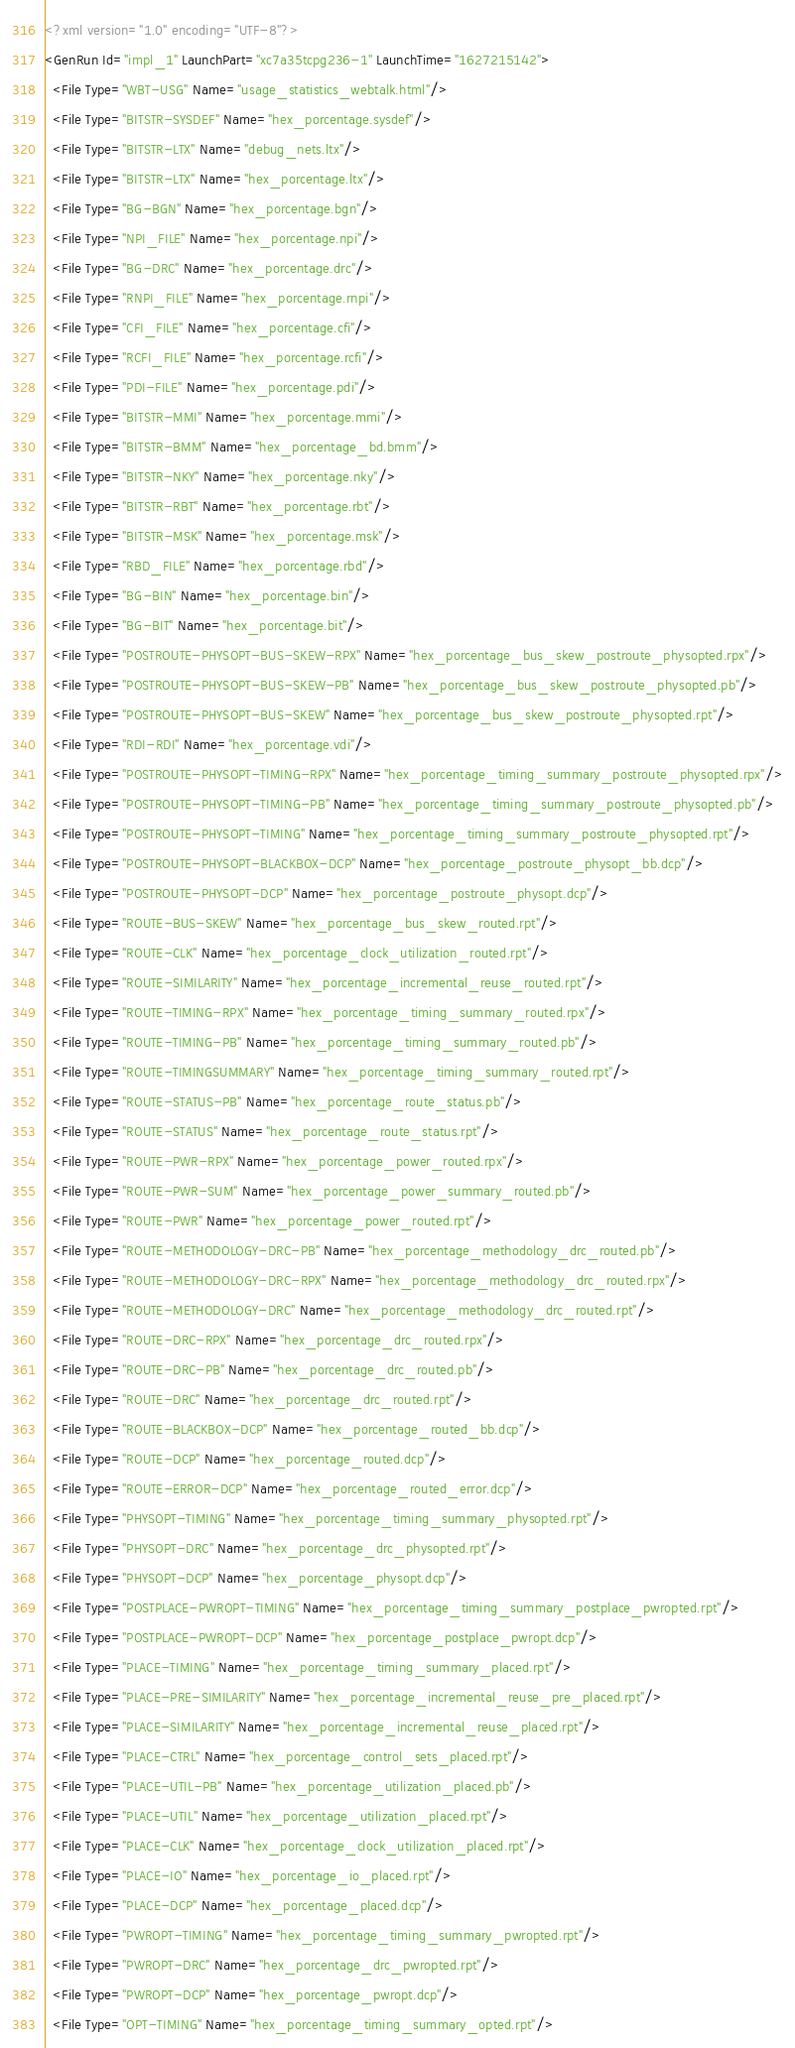<code> <loc_0><loc_0><loc_500><loc_500><_XML_><?xml version="1.0" encoding="UTF-8"?>
<GenRun Id="impl_1" LaunchPart="xc7a35tcpg236-1" LaunchTime="1627215142">
  <File Type="WBT-USG" Name="usage_statistics_webtalk.html"/>
  <File Type="BITSTR-SYSDEF" Name="hex_porcentage.sysdef"/>
  <File Type="BITSTR-LTX" Name="debug_nets.ltx"/>
  <File Type="BITSTR-LTX" Name="hex_porcentage.ltx"/>
  <File Type="BG-BGN" Name="hex_porcentage.bgn"/>
  <File Type="NPI_FILE" Name="hex_porcentage.npi"/>
  <File Type="BG-DRC" Name="hex_porcentage.drc"/>
  <File Type="RNPI_FILE" Name="hex_porcentage.rnpi"/>
  <File Type="CFI_FILE" Name="hex_porcentage.cfi"/>
  <File Type="RCFI_FILE" Name="hex_porcentage.rcfi"/>
  <File Type="PDI-FILE" Name="hex_porcentage.pdi"/>
  <File Type="BITSTR-MMI" Name="hex_porcentage.mmi"/>
  <File Type="BITSTR-BMM" Name="hex_porcentage_bd.bmm"/>
  <File Type="BITSTR-NKY" Name="hex_porcentage.nky"/>
  <File Type="BITSTR-RBT" Name="hex_porcentage.rbt"/>
  <File Type="BITSTR-MSK" Name="hex_porcentage.msk"/>
  <File Type="RBD_FILE" Name="hex_porcentage.rbd"/>
  <File Type="BG-BIN" Name="hex_porcentage.bin"/>
  <File Type="BG-BIT" Name="hex_porcentage.bit"/>
  <File Type="POSTROUTE-PHYSOPT-BUS-SKEW-RPX" Name="hex_porcentage_bus_skew_postroute_physopted.rpx"/>
  <File Type="POSTROUTE-PHYSOPT-BUS-SKEW-PB" Name="hex_porcentage_bus_skew_postroute_physopted.pb"/>
  <File Type="POSTROUTE-PHYSOPT-BUS-SKEW" Name="hex_porcentage_bus_skew_postroute_physopted.rpt"/>
  <File Type="RDI-RDI" Name="hex_porcentage.vdi"/>
  <File Type="POSTROUTE-PHYSOPT-TIMING-RPX" Name="hex_porcentage_timing_summary_postroute_physopted.rpx"/>
  <File Type="POSTROUTE-PHYSOPT-TIMING-PB" Name="hex_porcentage_timing_summary_postroute_physopted.pb"/>
  <File Type="POSTROUTE-PHYSOPT-TIMING" Name="hex_porcentage_timing_summary_postroute_physopted.rpt"/>
  <File Type="POSTROUTE-PHYSOPT-BLACKBOX-DCP" Name="hex_porcentage_postroute_physopt_bb.dcp"/>
  <File Type="POSTROUTE-PHYSOPT-DCP" Name="hex_porcentage_postroute_physopt.dcp"/>
  <File Type="ROUTE-BUS-SKEW" Name="hex_porcentage_bus_skew_routed.rpt"/>
  <File Type="ROUTE-CLK" Name="hex_porcentage_clock_utilization_routed.rpt"/>
  <File Type="ROUTE-SIMILARITY" Name="hex_porcentage_incremental_reuse_routed.rpt"/>
  <File Type="ROUTE-TIMING-RPX" Name="hex_porcentage_timing_summary_routed.rpx"/>
  <File Type="ROUTE-TIMING-PB" Name="hex_porcentage_timing_summary_routed.pb"/>
  <File Type="ROUTE-TIMINGSUMMARY" Name="hex_porcentage_timing_summary_routed.rpt"/>
  <File Type="ROUTE-STATUS-PB" Name="hex_porcentage_route_status.pb"/>
  <File Type="ROUTE-STATUS" Name="hex_porcentage_route_status.rpt"/>
  <File Type="ROUTE-PWR-RPX" Name="hex_porcentage_power_routed.rpx"/>
  <File Type="ROUTE-PWR-SUM" Name="hex_porcentage_power_summary_routed.pb"/>
  <File Type="ROUTE-PWR" Name="hex_porcentage_power_routed.rpt"/>
  <File Type="ROUTE-METHODOLOGY-DRC-PB" Name="hex_porcentage_methodology_drc_routed.pb"/>
  <File Type="ROUTE-METHODOLOGY-DRC-RPX" Name="hex_porcentage_methodology_drc_routed.rpx"/>
  <File Type="ROUTE-METHODOLOGY-DRC" Name="hex_porcentage_methodology_drc_routed.rpt"/>
  <File Type="ROUTE-DRC-RPX" Name="hex_porcentage_drc_routed.rpx"/>
  <File Type="ROUTE-DRC-PB" Name="hex_porcentage_drc_routed.pb"/>
  <File Type="ROUTE-DRC" Name="hex_porcentage_drc_routed.rpt"/>
  <File Type="ROUTE-BLACKBOX-DCP" Name="hex_porcentage_routed_bb.dcp"/>
  <File Type="ROUTE-DCP" Name="hex_porcentage_routed.dcp"/>
  <File Type="ROUTE-ERROR-DCP" Name="hex_porcentage_routed_error.dcp"/>
  <File Type="PHYSOPT-TIMING" Name="hex_porcentage_timing_summary_physopted.rpt"/>
  <File Type="PHYSOPT-DRC" Name="hex_porcentage_drc_physopted.rpt"/>
  <File Type="PHYSOPT-DCP" Name="hex_porcentage_physopt.dcp"/>
  <File Type="POSTPLACE-PWROPT-TIMING" Name="hex_porcentage_timing_summary_postplace_pwropted.rpt"/>
  <File Type="POSTPLACE-PWROPT-DCP" Name="hex_porcentage_postplace_pwropt.dcp"/>
  <File Type="PLACE-TIMING" Name="hex_porcentage_timing_summary_placed.rpt"/>
  <File Type="PLACE-PRE-SIMILARITY" Name="hex_porcentage_incremental_reuse_pre_placed.rpt"/>
  <File Type="PLACE-SIMILARITY" Name="hex_porcentage_incremental_reuse_placed.rpt"/>
  <File Type="PLACE-CTRL" Name="hex_porcentage_control_sets_placed.rpt"/>
  <File Type="PLACE-UTIL-PB" Name="hex_porcentage_utilization_placed.pb"/>
  <File Type="PLACE-UTIL" Name="hex_porcentage_utilization_placed.rpt"/>
  <File Type="PLACE-CLK" Name="hex_porcentage_clock_utilization_placed.rpt"/>
  <File Type="PLACE-IO" Name="hex_porcentage_io_placed.rpt"/>
  <File Type="PLACE-DCP" Name="hex_porcentage_placed.dcp"/>
  <File Type="PWROPT-TIMING" Name="hex_porcentage_timing_summary_pwropted.rpt"/>
  <File Type="PWROPT-DRC" Name="hex_porcentage_drc_pwropted.rpt"/>
  <File Type="PWROPT-DCP" Name="hex_porcentage_pwropt.dcp"/>
  <File Type="OPT-TIMING" Name="hex_porcentage_timing_summary_opted.rpt"/></code> 